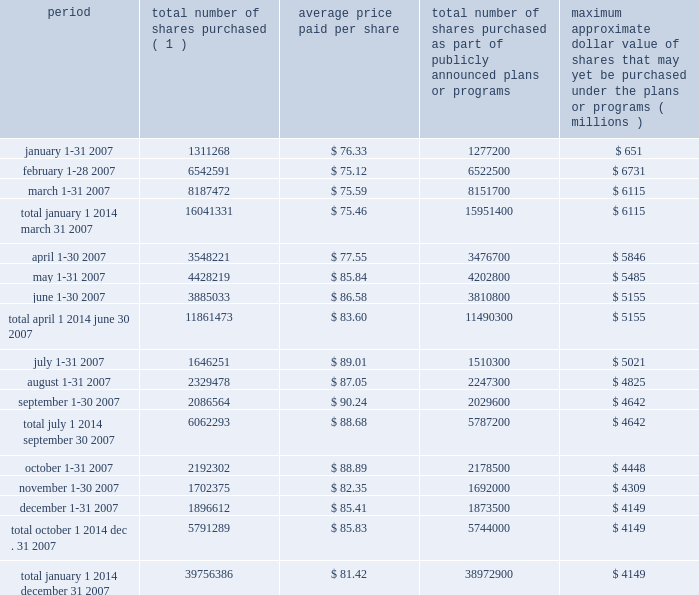Issuer purchases of equity securities ( registered pursuant to section 12 of the exchange act ) period number of shares purchased average price paid per share number of shares purchased as part of publicly announced plans or programs maximum approximate dollar value of shares that may yet be purchased under the plans or programs ( 1 ) ( millions ) .
( 1 ) the total number of shares purchased includes : ( i ) shares purchased under the board 2019s authorizations described above , and ( ii ) shares purchased in connection with the exercise of stock options ( which totaled 34068 shares in january 2007 , 20091 shares in february 2007 , 35772 shares in march 2007 , 71521 shares in april 2007 , 225419 shares in may 2007 , 74233 shares in june 2007 , 135951 shares in july 2007 , 82178 shares in august 2007 , 56964 shares in september 2007 , 13802 shares in october 2007 , 10375 shares in november 2007 , and 23112 shares in december 2007 ) . .
What was the percent of the total tumber of shares purchased that was not of the shares purchased as part of publicly announced plans or programs? 
Computations: ((39756386 - 38972900) / 38972900)
Answer: 0.0201. 